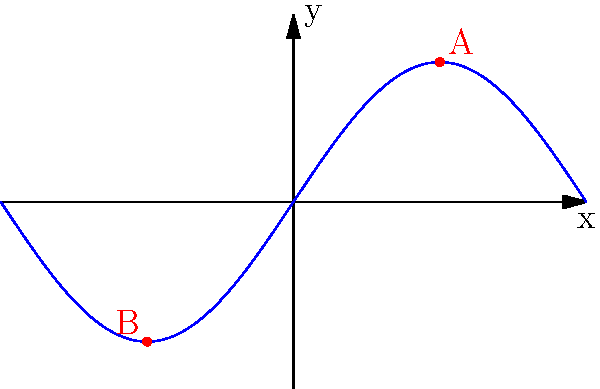In surf forecasting, understanding wave symmetry is crucial. The graph above represents a simplified wave pattern. Points A and B are symmetric about the y-axis. If the coordinates of point A are $(\frac{\pi}{2}, \frac{3\sqrt{2}}{2})$, what are the coordinates of point B? To find the coordinates of point B, we can use the properties of reflection symmetry about the y-axis:

1. In a reflection about the y-axis, the x-coordinate changes sign, while the y-coordinate remains the same.

2. Given: Point A has coordinates $(\frac{\pi}{2}, \frac{3\sqrt{2}}{2})$

3. To find the x-coordinate of B:
   - The x-coordinate will have the same magnitude as A but opposite sign
   - x-coordinate of B = $-\frac{\pi}{2}$

4. To find the y-coordinate of B:
   - The y-coordinate remains unchanged in a reflection about the y-axis
   - y-coordinate of B = $\frac{3\sqrt{2}}{2}$

5. Therefore, the coordinates of point B are $(-\frac{\pi}{2}, \frac{3\sqrt{2}}{2})$

This reflection symmetry in wave patterns is important in surf forecasting as it helps predict wave behavior and symmetry on both sides of a beach or reef break.
Answer: $(-\frac{\pi}{2}, \frac{3\sqrt{2}}{2})$ 